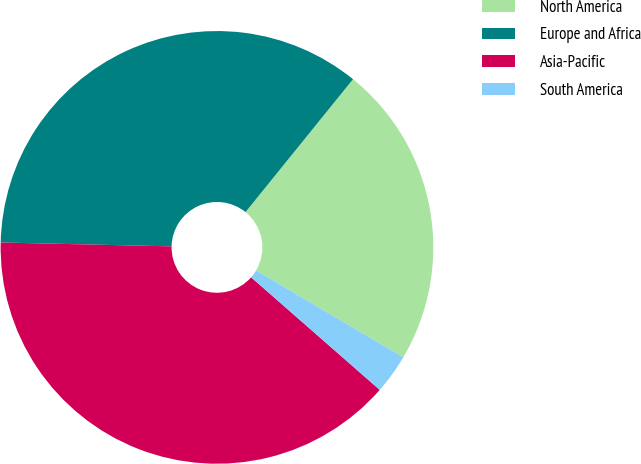Convert chart to OTSL. <chart><loc_0><loc_0><loc_500><loc_500><pie_chart><fcel>North America<fcel>Europe and Africa<fcel>Asia-Pacific<fcel>South America<nl><fcel>22.66%<fcel>35.47%<fcel>38.92%<fcel>2.96%<nl></chart> 